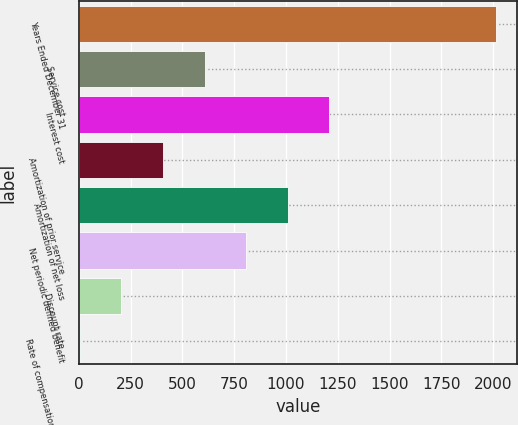<chart> <loc_0><loc_0><loc_500><loc_500><bar_chart><fcel>Years Ended December 31<fcel>Service cost<fcel>Interest cost<fcel>Amortization of prior service<fcel>Amortization of net loss<fcel>Net periodic defined benefit<fcel>Discount rate<fcel>Rate of compensation increase<nl><fcel>2013<fcel>606.7<fcel>1209.4<fcel>405.8<fcel>1008.5<fcel>807.6<fcel>204.9<fcel>4<nl></chart> 